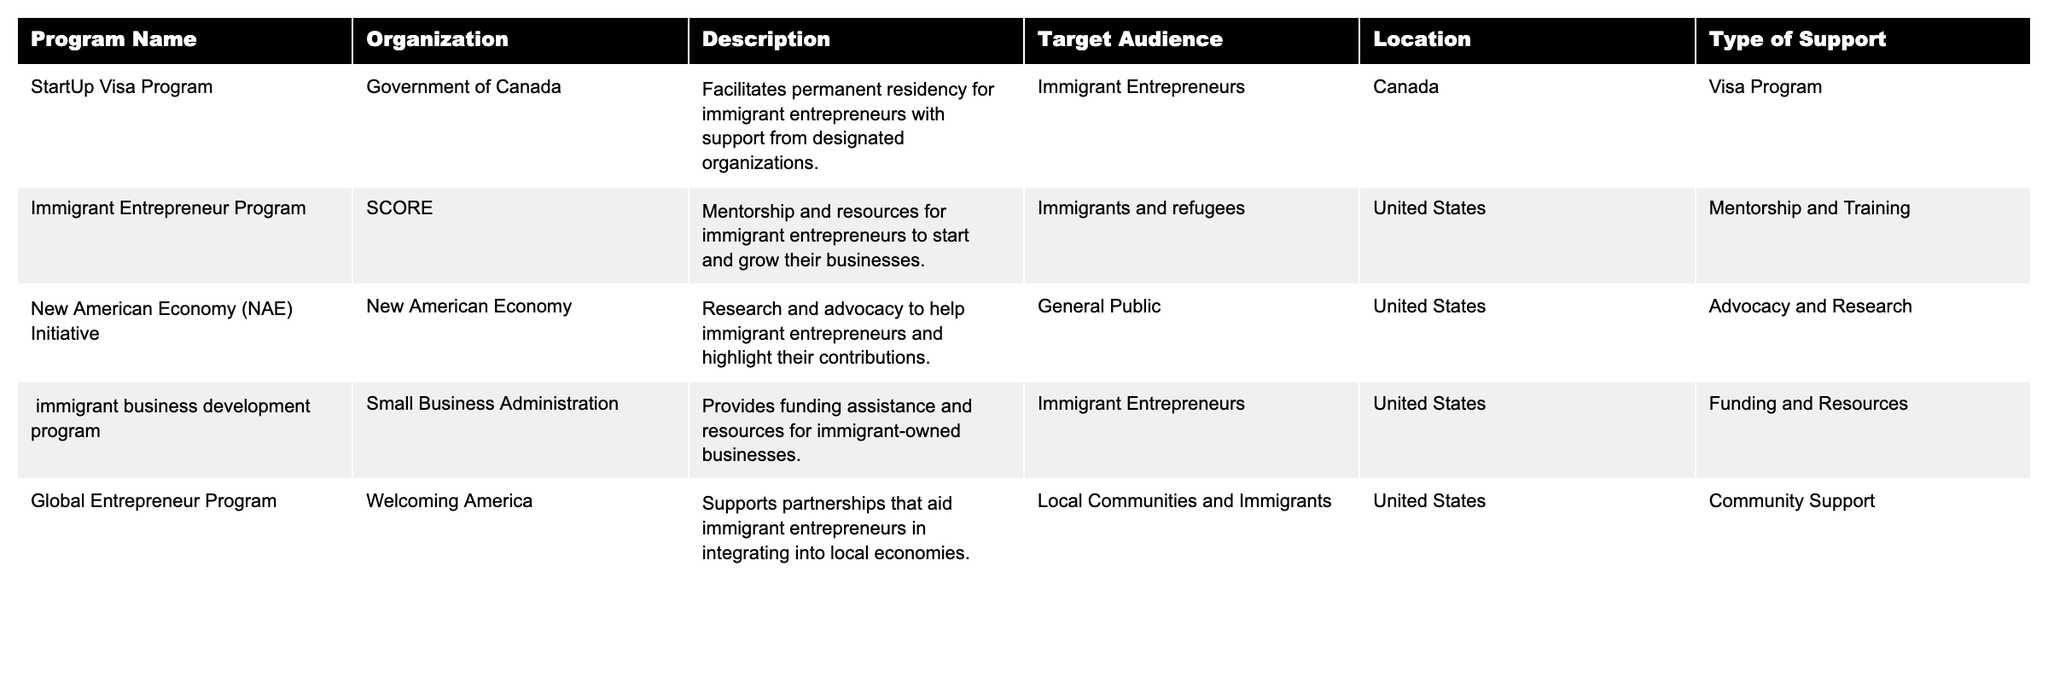What is the main type of support offered by the "StartUp Visa Program"? The "StartUp Visa Program" primarily offers a visa program that facilitates permanent residency for immigrant entrepreneurs with the support of designated organizations.
Answer: Visa Program Which organization runs the "New American Economy (NAE) Initiative"? The "New American Economy (NAE) Initiative" is run by the organization called New American Economy.
Answer: New American Economy How many programs listed target immigrant entrepreneurs specifically? The table lists four programs that target immigrant entrepreneurs specifically: "StartUp Visa Program," "Immigrant Entrepreneur Program," "immigrant business development program," and "Global Entrepreneur Program."
Answer: 4 Is the "Immigrant Entrepreneur Program" available in Canada? No, the "Immigrant Entrepreneur Program" is available only in the United States, as indicated by the location column in the table.
Answer: No Which program provides funding assistance for immigrant-owned businesses? The program that provides funding assistance for immigrant-owned businesses is the "immigrant business development program" offered by the Small Business Administration.
Answer: immigrant business development program What type of support does the "Global Entrepreneur Program" offer? The "Global Entrepreneur Program" offers community support that focuses on partnerships to aid immigrant entrepreneurs in integrating into local economies.
Answer: Community Support Which country has the most support programs listed in the table? The table has three programs available in the United States and two in Canada. Therefore, the United States has the most support programs listed.
Answer: United States Are there any programs focused on advocacy and research for immigrant entrepreneurs? Yes, the "New American Economy (NAE) Initiative" focuses on research and advocacy to help immigrant entrepreneurs and highlight their contributions.
Answer: Yes What is the difference in support type between the "Immigrant Entrepreneur Program" and the "StartUp Visa Program"? The "Immigrant Entrepreneur Program" provides mentorship and training, while the "StartUp Visa Program" facilitates permanent residency, indicating that they support immigrant entrepreneurs in different ways.
Answer: Mentorship and Visa Program How many programs in the table are specifically aimed at immigrants and refugees? There are two programs specifically aimed at immigrants and refugees: "Immigrant Entrepreneur Program" and "Global Entrepreneur Program."
Answer: 2 Which program is associated with Welcoming America? The "Global Entrepreneur Program" is associated with Welcoming America as indicated in the organization column of the table.
Answer: Global Entrepreneur Program What type of audience is the "New American Economy (NAE) Initiative" aimed at? The "New American Economy (NAE) Initiative" is aimed at the general public.
Answer: General Public 